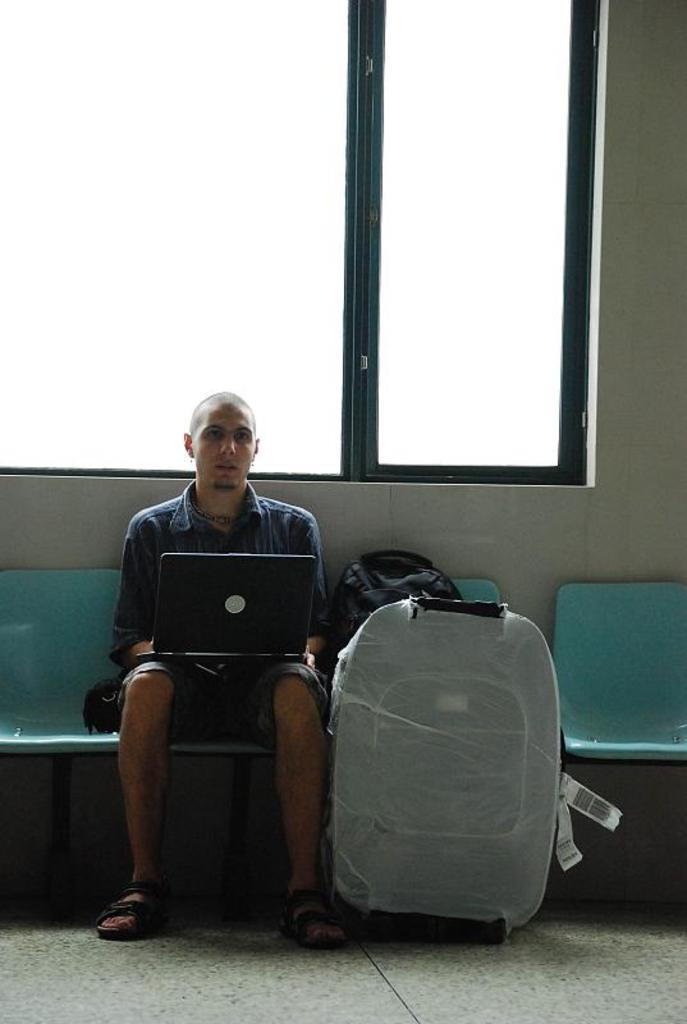What is the person in the image doing? The person is sitting on a chair. What object is the person holding in the image? The person is carrying a laptop. What is located beside the person? There is a bag and luggage beside the person. What can be seen in the background of the image? There is a window with a door in the image. How many jellyfish can be seen swimming in the image? There are no jellyfish present in the image. What type of skin is visible on the person in the image? The image does not provide enough detail to determine the type of skin visible on the person. 